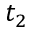<formula> <loc_0><loc_0><loc_500><loc_500>t _ { 2 }</formula> 